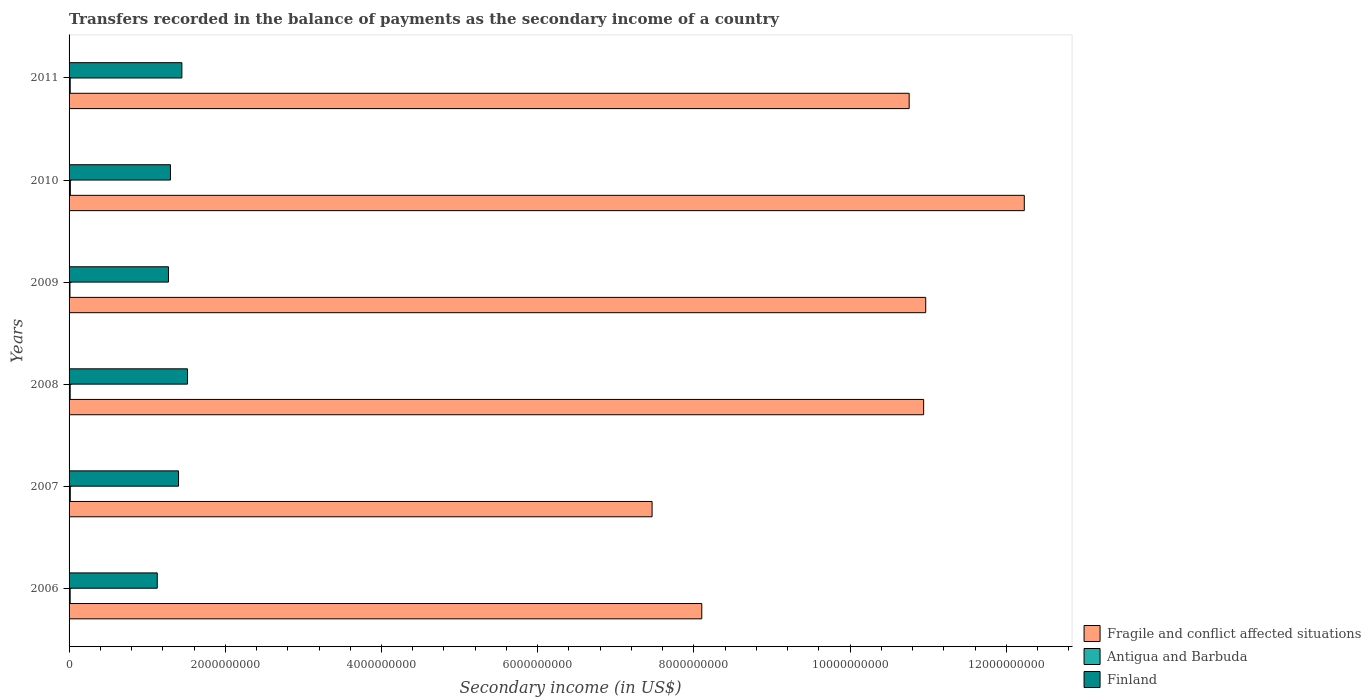How many groups of bars are there?
Provide a succinct answer. 6. Are the number of bars per tick equal to the number of legend labels?
Your answer should be very brief. Yes. How many bars are there on the 3rd tick from the bottom?
Keep it short and to the point. 3. What is the label of the 2nd group of bars from the top?
Ensure brevity in your answer.  2010. In how many cases, is the number of bars for a given year not equal to the number of legend labels?
Provide a succinct answer. 0. What is the secondary income of in Finland in 2010?
Make the answer very short. 1.30e+09. Across all years, what is the maximum secondary income of in Fragile and conflict affected situations?
Your answer should be compact. 1.22e+1. Across all years, what is the minimum secondary income of in Antigua and Barbuda?
Offer a terse response. 1.14e+07. What is the total secondary income of in Antigua and Barbuda in the graph?
Give a very brief answer. 8.55e+07. What is the difference between the secondary income of in Finland in 2006 and that in 2011?
Your answer should be very brief. -3.15e+08. What is the difference between the secondary income of in Finland in 2009 and the secondary income of in Fragile and conflict affected situations in 2007?
Provide a succinct answer. -6.19e+09. What is the average secondary income of in Antigua and Barbuda per year?
Your response must be concise. 1.42e+07. In the year 2009, what is the difference between the secondary income of in Fragile and conflict affected situations and secondary income of in Finland?
Offer a terse response. 9.70e+09. In how many years, is the secondary income of in Fragile and conflict affected situations greater than 1200000000 US$?
Provide a short and direct response. 6. What is the ratio of the secondary income of in Finland in 2006 to that in 2008?
Provide a short and direct response. 0.74. Is the secondary income of in Finland in 2007 less than that in 2011?
Offer a terse response. Yes. Is the difference between the secondary income of in Fragile and conflict affected situations in 2007 and 2009 greater than the difference between the secondary income of in Finland in 2007 and 2009?
Offer a very short reply. No. What is the difference between the highest and the second highest secondary income of in Antigua and Barbuda?
Provide a short and direct response. 4.28e+05. What is the difference between the highest and the lowest secondary income of in Antigua and Barbuda?
Offer a very short reply. 4.58e+06. In how many years, is the secondary income of in Antigua and Barbuda greater than the average secondary income of in Antigua and Barbuda taken over all years?
Ensure brevity in your answer.  3. What does the 1st bar from the bottom in 2008 represents?
Make the answer very short. Fragile and conflict affected situations. How many bars are there?
Offer a very short reply. 18. How many years are there in the graph?
Your answer should be very brief. 6. What is the difference between two consecutive major ticks on the X-axis?
Your response must be concise. 2.00e+09. Does the graph contain grids?
Your answer should be compact. No. Where does the legend appear in the graph?
Give a very brief answer. Bottom right. What is the title of the graph?
Make the answer very short. Transfers recorded in the balance of payments as the secondary income of a country. Does "Switzerland" appear as one of the legend labels in the graph?
Keep it short and to the point. No. What is the label or title of the X-axis?
Your answer should be compact. Secondary income (in US$). What is the Secondary income (in US$) in Fragile and conflict affected situations in 2006?
Provide a short and direct response. 8.10e+09. What is the Secondary income (in US$) of Antigua and Barbuda in 2006?
Make the answer very short. 1.39e+07. What is the Secondary income (in US$) of Finland in 2006?
Give a very brief answer. 1.13e+09. What is the Secondary income (in US$) in Fragile and conflict affected situations in 2007?
Your response must be concise. 7.46e+09. What is the Secondary income (in US$) in Antigua and Barbuda in 2007?
Provide a short and direct response. 1.56e+07. What is the Secondary income (in US$) in Finland in 2007?
Give a very brief answer. 1.40e+09. What is the Secondary income (in US$) in Fragile and conflict affected situations in 2008?
Ensure brevity in your answer.  1.09e+1. What is the Secondary income (in US$) of Antigua and Barbuda in 2008?
Keep it short and to the point. 1.40e+07. What is the Secondary income (in US$) in Finland in 2008?
Provide a succinct answer. 1.52e+09. What is the Secondary income (in US$) of Fragile and conflict affected situations in 2009?
Provide a succinct answer. 1.10e+1. What is the Secondary income (in US$) in Antigua and Barbuda in 2009?
Give a very brief answer. 1.14e+07. What is the Secondary income (in US$) of Finland in 2009?
Keep it short and to the point. 1.27e+09. What is the Secondary income (in US$) of Fragile and conflict affected situations in 2010?
Your answer should be compact. 1.22e+1. What is the Secondary income (in US$) of Antigua and Barbuda in 2010?
Your answer should be compact. 1.60e+07. What is the Secondary income (in US$) of Finland in 2010?
Offer a terse response. 1.30e+09. What is the Secondary income (in US$) in Fragile and conflict affected situations in 2011?
Offer a very short reply. 1.08e+1. What is the Secondary income (in US$) in Antigua and Barbuda in 2011?
Give a very brief answer. 1.45e+07. What is the Secondary income (in US$) in Finland in 2011?
Provide a short and direct response. 1.44e+09. Across all years, what is the maximum Secondary income (in US$) in Fragile and conflict affected situations?
Your response must be concise. 1.22e+1. Across all years, what is the maximum Secondary income (in US$) of Antigua and Barbuda?
Give a very brief answer. 1.60e+07. Across all years, what is the maximum Secondary income (in US$) in Finland?
Make the answer very short. 1.52e+09. Across all years, what is the minimum Secondary income (in US$) in Fragile and conflict affected situations?
Offer a terse response. 7.46e+09. Across all years, what is the minimum Secondary income (in US$) in Antigua and Barbuda?
Make the answer very short. 1.14e+07. Across all years, what is the minimum Secondary income (in US$) in Finland?
Provide a succinct answer. 1.13e+09. What is the total Secondary income (in US$) of Fragile and conflict affected situations in the graph?
Provide a short and direct response. 6.05e+1. What is the total Secondary income (in US$) of Antigua and Barbuda in the graph?
Your answer should be very brief. 8.55e+07. What is the total Secondary income (in US$) of Finland in the graph?
Offer a very short reply. 8.06e+09. What is the difference between the Secondary income (in US$) in Fragile and conflict affected situations in 2006 and that in 2007?
Ensure brevity in your answer.  6.36e+08. What is the difference between the Secondary income (in US$) in Antigua and Barbuda in 2006 and that in 2007?
Offer a terse response. -1.71e+06. What is the difference between the Secondary income (in US$) of Finland in 2006 and that in 2007?
Your answer should be compact. -2.72e+08. What is the difference between the Secondary income (in US$) of Fragile and conflict affected situations in 2006 and that in 2008?
Ensure brevity in your answer.  -2.84e+09. What is the difference between the Secondary income (in US$) in Antigua and Barbuda in 2006 and that in 2008?
Give a very brief answer. -1.47e+05. What is the difference between the Secondary income (in US$) of Finland in 2006 and that in 2008?
Make the answer very short. -3.87e+08. What is the difference between the Secondary income (in US$) in Fragile and conflict affected situations in 2006 and that in 2009?
Provide a succinct answer. -2.87e+09. What is the difference between the Secondary income (in US$) in Antigua and Barbuda in 2006 and that in 2009?
Offer a terse response. 2.44e+06. What is the difference between the Secondary income (in US$) of Finland in 2006 and that in 2009?
Provide a short and direct response. -1.43e+08. What is the difference between the Secondary income (in US$) in Fragile and conflict affected situations in 2006 and that in 2010?
Your response must be concise. -4.13e+09. What is the difference between the Secondary income (in US$) of Antigua and Barbuda in 2006 and that in 2010?
Provide a short and direct response. -2.14e+06. What is the difference between the Secondary income (in US$) in Finland in 2006 and that in 2010?
Your response must be concise. -1.69e+08. What is the difference between the Secondary income (in US$) in Fragile and conflict affected situations in 2006 and that in 2011?
Your answer should be compact. -2.66e+09. What is the difference between the Secondary income (in US$) in Antigua and Barbuda in 2006 and that in 2011?
Make the answer very short. -6.30e+05. What is the difference between the Secondary income (in US$) of Finland in 2006 and that in 2011?
Ensure brevity in your answer.  -3.15e+08. What is the difference between the Secondary income (in US$) in Fragile and conflict affected situations in 2007 and that in 2008?
Your response must be concise. -3.48e+09. What is the difference between the Secondary income (in US$) in Antigua and Barbuda in 2007 and that in 2008?
Offer a very short reply. 1.57e+06. What is the difference between the Secondary income (in US$) in Finland in 2007 and that in 2008?
Offer a terse response. -1.15e+08. What is the difference between the Secondary income (in US$) in Fragile and conflict affected situations in 2007 and that in 2009?
Keep it short and to the point. -3.50e+09. What is the difference between the Secondary income (in US$) in Antigua and Barbuda in 2007 and that in 2009?
Make the answer very short. 4.15e+06. What is the difference between the Secondary income (in US$) in Finland in 2007 and that in 2009?
Ensure brevity in your answer.  1.29e+08. What is the difference between the Secondary income (in US$) in Fragile and conflict affected situations in 2007 and that in 2010?
Ensure brevity in your answer.  -4.77e+09. What is the difference between the Secondary income (in US$) of Antigua and Barbuda in 2007 and that in 2010?
Ensure brevity in your answer.  -4.28e+05. What is the difference between the Secondary income (in US$) in Finland in 2007 and that in 2010?
Provide a short and direct response. 1.03e+08. What is the difference between the Secondary income (in US$) in Fragile and conflict affected situations in 2007 and that in 2011?
Offer a very short reply. -3.29e+09. What is the difference between the Secondary income (in US$) of Antigua and Barbuda in 2007 and that in 2011?
Give a very brief answer. 1.08e+06. What is the difference between the Secondary income (in US$) of Finland in 2007 and that in 2011?
Your answer should be compact. -4.30e+07. What is the difference between the Secondary income (in US$) in Fragile and conflict affected situations in 2008 and that in 2009?
Ensure brevity in your answer.  -2.65e+07. What is the difference between the Secondary income (in US$) of Antigua and Barbuda in 2008 and that in 2009?
Offer a very short reply. 2.59e+06. What is the difference between the Secondary income (in US$) of Finland in 2008 and that in 2009?
Ensure brevity in your answer.  2.44e+08. What is the difference between the Secondary income (in US$) of Fragile and conflict affected situations in 2008 and that in 2010?
Your response must be concise. -1.29e+09. What is the difference between the Secondary income (in US$) in Antigua and Barbuda in 2008 and that in 2010?
Provide a short and direct response. -2.00e+06. What is the difference between the Secondary income (in US$) of Finland in 2008 and that in 2010?
Make the answer very short. 2.18e+08. What is the difference between the Secondary income (in US$) in Fragile and conflict affected situations in 2008 and that in 2011?
Ensure brevity in your answer.  1.85e+08. What is the difference between the Secondary income (in US$) in Antigua and Barbuda in 2008 and that in 2011?
Your answer should be compact. -4.83e+05. What is the difference between the Secondary income (in US$) in Finland in 2008 and that in 2011?
Your answer should be compact. 7.19e+07. What is the difference between the Secondary income (in US$) in Fragile and conflict affected situations in 2009 and that in 2010?
Your response must be concise. -1.26e+09. What is the difference between the Secondary income (in US$) of Antigua and Barbuda in 2009 and that in 2010?
Your answer should be compact. -4.58e+06. What is the difference between the Secondary income (in US$) in Finland in 2009 and that in 2010?
Provide a succinct answer. -2.53e+07. What is the difference between the Secondary income (in US$) of Fragile and conflict affected situations in 2009 and that in 2011?
Offer a terse response. 2.12e+08. What is the difference between the Secondary income (in US$) of Antigua and Barbuda in 2009 and that in 2011?
Your answer should be very brief. -3.07e+06. What is the difference between the Secondary income (in US$) of Finland in 2009 and that in 2011?
Offer a terse response. -1.72e+08. What is the difference between the Secondary income (in US$) of Fragile and conflict affected situations in 2010 and that in 2011?
Your answer should be very brief. 1.47e+09. What is the difference between the Secondary income (in US$) in Antigua and Barbuda in 2010 and that in 2011?
Provide a short and direct response. 1.51e+06. What is the difference between the Secondary income (in US$) in Finland in 2010 and that in 2011?
Offer a very short reply. -1.46e+08. What is the difference between the Secondary income (in US$) in Fragile and conflict affected situations in 2006 and the Secondary income (in US$) in Antigua and Barbuda in 2007?
Your answer should be compact. 8.09e+09. What is the difference between the Secondary income (in US$) of Fragile and conflict affected situations in 2006 and the Secondary income (in US$) of Finland in 2007?
Give a very brief answer. 6.70e+09. What is the difference between the Secondary income (in US$) in Antigua and Barbuda in 2006 and the Secondary income (in US$) in Finland in 2007?
Give a very brief answer. -1.39e+09. What is the difference between the Secondary income (in US$) in Fragile and conflict affected situations in 2006 and the Secondary income (in US$) in Antigua and Barbuda in 2008?
Ensure brevity in your answer.  8.09e+09. What is the difference between the Secondary income (in US$) of Fragile and conflict affected situations in 2006 and the Secondary income (in US$) of Finland in 2008?
Provide a short and direct response. 6.58e+09. What is the difference between the Secondary income (in US$) of Antigua and Barbuda in 2006 and the Secondary income (in US$) of Finland in 2008?
Your response must be concise. -1.50e+09. What is the difference between the Secondary income (in US$) of Fragile and conflict affected situations in 2006 and the Secondary income (in US$) of Antigua and Barbuda in 2009?
Provide a succinct answer. 8.09e+09. What is the difference between the Secondary income (in US$) in Fragile and conflict affected situations in 2006 and the Secondary income (in US$) in Finland in 2009?
Make the answer very short. 6.83e+09. What is the difference between the Secondary income (in US$) in Antigua and Barbuda in 2006 and the Secondary income (in US$) in Finland in 2009?
Offer a very short reply. -1.26e+09. What is the difference between the Secondary income (in US$) in Fragile and conflict affected situations in 2006 and the Secondary income (in US$) in Antigua and Barbuda in 2010?
Provide a short and direct response. 8.09e+09. What is the difference between the Secondary income (in US$) of Fragile and conflict affected situations in 2006 and the Secondary income (in US$) of Finland in 2010?
Your answer should be compact. 6.80e+09. What is the difference between the Secondary income (in US$) in Antigua and Barbuda in 2006 and the Secondary income (in US$) in Finland in 2010?
Provide a succinct answer. -1.28e+09. What is the difference between the Secondary income (in US$) of Fragile and conflict affected situations in 2006 and the Secondary income (in US$) of Antigua and Barbuda in 2011?
Offer a terse response. 8.09e+09. What is the difference between the Secondary income (in US$) of Fragile and conflict affected situations in 2006 and the Secondary income (in US$) of Finland in 2011?
Your response must be concise. 6.66e+09. What is the difference between the Secondary income (in US$) of Antigua and Barbuda in 2006 and the Secondary income (in US$) of Finland in 2011?
Provide a succinct answer. -1.43e+09. What is the difference between the Secondary income (in US$) in Fragile and conflict affected situations in 2007 and the Secondary income (in US$) in Antigua and Barbuda in 2008?
Your response must be concise. 7.45e+09. What is the difference between the Secondary income (in US$) in Fragile and conflict affected situations in 2007 and the Secondary income (in US$) in Finland in 2008?
Ensure brevity in your answer.  5.95e+09. What is the difference between the Secondary income (in US$) of Antigua and Barbuda in 2007 and the Secondary income (in US$) of Finland in 2008?
Give a very brief answer. -1.50e+09. What is the difference between the Secondary income (in US$) of Fragile and conflict affected situations in 2007 and the Secondary income (in US$) of Antigua and Barbuda in 2009?
Your response must be concise. 7.45e+09. What is the difference between the Secondary income (in US$) of Fragile and conflict affected situations in 2007 and the Secondary income (in US$) of Finland in 2009?
Keep it short and to the point. 6.19e+09. What is the difference between the Secondary income (in US$) in Antigua and Barbuda in 2007 and the Secondary income (in US$) in Finland in 2009?
Your answer should be compact. -1.26e+09. What is the difference between the Secondary income (in US$) of Fragile and conflict affected situations in 2007 and the Secondary income (in US$) of Antigua and Barbuda in 2010?
Offer a terse response. 7.45e+09. What is the difference between the Secondary income (in US$) of Fragile and conflict affected situations in 2007 and the Secondary income (in US$) of Finland in 2010?
Offer a terse response. 6.17e+09. What is the difference between the Secondary income (in US$) in Antigua and Barbuda in 2007 and the Secondary income (in US$) in Finland in 2010?
Offer a very short reply. -1.28e+09. What is the difference between the Secondary income (in US$) in Fragile and conflict affected situations in 2007 and the Secondary income (in US$) in Antigua and Barbuda in 2011?
Provide a short and direct response. 7.45e+09. What is the difference between the Secondary income (in US$) in Fragile and conflict affected situations in 2007 and the Secondary income (in US$) in Finland in 2011?
Your answer should be very brief. 6.02e+09. What is the difference between the Secondary income (in US$) of Antigua and Barbuda in 2007 and the Secondary income (in US$) of Finland in 2011?
Give a very brief answer. -1.43e+09. What is the difference between the Secondary income (in US$) of Fragile and conflict affected situations in 2008 and the Secondary income (in US$) of Antigua and Barbuda in 2009?
Give a very brief answer. 1.09e+1. What is the difference between the Secondary income (in US$) of Fragile and conflict affected situations in 2008 and the Secondary income (in US$) of Finland in 2009?
Offer a terse response. 9.67e+09. What is the difference between the Secondary income (in US$) of Antigua and Barbuda in 2008 and the Secondary income (in US$) of Finland in 2009?
Ensure brevity in your answer.  -1.26e+09. What is the difference between the Secondary income (in US$) in Fragile and conflict affected situations in 2008 and the Secondary income (in US$) in Antigua and Barbuda in 2010?
Make the answer very short. 1.09e+1. What is the difference between the Secondary income (in US$) of Fragile and conflict affected situations in 2008 and the Secondary income (in US$) of Finland in 2010?
Your answer should be very brief. 9.64e+09. What is the difference between the Secondary income (in US$) in Antigua and Barbuda in 2008 and the Secondary income (in US$) in Finland in 2010?
Provide a short and direct response. -1.28e+09. What is the difference between the Secondary income (in US$) of Fragile and conflict affected situations in 2008 and the Secondary income (in US$) of Antigua and Barbuda in 2011?
Your answer should be compact. 1.09e+1. What is the difference between the Secondary income (in US$) in Fragile and conflict affected situations in 2008 and the Secondary income (in US$) in Finland in 2011?
Offer a terse response. 9.50e+09. What is the difference between the Secondary income (in US$) in Antigua and Barbuda in 2008 and the Secondary income (in US$) in Finland in 2011?
Your answer should be compact. -1.43e+09. What is the difference between the Secondary income (in US$) in Fragile and conflict affected situations in 2009 and the Secondary income (in US$) in Antigua and Barbuda in 2010?
Make the answer very short. 1.10e+1. What is the difference between the Secondary income (in US$) in Fragile and conflict affected situations in 2009 and the Secondary income (in US$) in Finland in 2010?
Offer a terse response. 9.67e+09. What is the difference between the Secondary income (in US$) of Antigua and Barbuda in 2009 and the Secondary income (in US$) of Finland in 2010?
Ensure brevity in your answer.  -1.29e+09. What is the difference between the Secondary income (in US$) in Fragile and conflict affected situations in 2009 and the Secondary income (in US$) in Antigua and Barbuda in 2011?
Ensure brevity in your answer.  1.10e+1. What is the difference between the Secondary income (in US$) in Fragile and conflict affected situations in 2009 and the Secondary income (in US$) in Finland in 2011?
Your answer should be very brief. 9.52e+09. What is the difference between the Secondary income (in US$) in Antigua and Barbuda in 2009 and the Secondary income (in US$) in Finland in 2011?
Make the answer very short. -1.43e+09. What is the difference between the Secondary income (in US$) of Fragile and conflict affected situations in 2010 and the Secondary income (in US$) of Antigua and Barbuda in 2011?
Ensure brevity in your answer.  1.22e+1. What is the difference between the Secondary income (in US$) in Fragile and conflict affected situations in 2010 and the Secondary income (in US$) in Finland in 2011?
Offer a terse response. 1.08e+1. What is the difference between the Secondary income (in US$) of Antigua and Barbuda in 2010 and the Secondary income (in US$) of Finland in 2011?
Provide a short and direct response. -1.43e+09. What is the average Secondary income (in US$) of Fragile and conflict affected situations per year?
Give a very brief answer. 1.01e+1. What is the average Secondary income (in US$) of Antigua and Barbuda per year?
Keep it short and to the point. 1.42e+07. What is the average Secondary income (in US$) of Finland per year?
Ensure brevity in your answer.  1.34e+09. In the year 2006, what is the difference between the Secondary income (in US$) of Fragile and conflict affected situations and Secondary income (in US$) of Antigua and Barbuda?
Your response must be concise. 8.09e+09. In the year 2006, what is the difference between the Secondary income (in US$) in Fragile and conflict affected situations and Secondary income (in US$) in Finland?
Your answer should be very brief. 6.97e+09. In the year 2006, what is the difference between the Secondary income (in US$) of Antigua and Barbuda and Secondary income (in US$) of Finland?
Offer a terse response. -1.12e+09. In the year 2007, what is the difference between the Secondary income (in US$) in Fragile and conflict affected situations and Secondary income (in US$) in Antigua and Barbuda?
Your answer should be compact. 7.45e+09. In the year 2007, what is the difference between the Secondary income (in US$) of Fragile and conflict affected situations and Secondary income (in US$) of Finland?
Keep it short and to the point. 6.06e+09. In the year 2007, what is the difference between the Secondary income (in US$) in Antigua and Barbuda and Secondary income (in US$) in Finland?
Ensure brevity in your answer.  -1.39e+09. In the year 2008, what is the difference between the Secondary income (in US$) of Fragile and conflict affected situations and Secondary income (in US$) of Antigua and Barbuda?
Ensure brevity in your answer.  1.09e+1. In the year 2008, what is the difference between the Secondary income (in US$) in Fragile and conflict affected situations and Secondary income (in US$) in Finland?
Offer a very short reply. 9.43e+09. In the year 2008, what is the difference between the Secondary income (in US$) in Antigua and Barbuda and Secondary income (in US$) in Finland?
Provide a succinct answer. -1.50e+09. In the year 2009, what is the difference between the Secondary income (in US$) in Fragile and conflict affected situations and Secondary income (in US$) in Antigua and Barbuda?
Provide a succinct answer. 1.10e+1. In the year 2009, what is the difference between the Secondary income (in US$) in Fragile and conflict affected situations and Secondary income (in US$) in Finland?
Provide a short and direct response. 9.70e+09. In the year 2009, what is the difference between the Secondary income (in US$) of Antigua and Barbuda and Secondary income (in US$) of Finland?
Offer a very short reply. -1.26e+09. In the year 2010, what is the difference between the Secondary income (in US$) of Fragile and conflict affected situations and Secondary income (in US$) of Antigua and Barbuda?
Provide a succinct answer. 1.22e+1. In the year 2010, what is the difference between the Secondary income (in US$) of Fragile and conflict affected situations and Secondary income (in US$) of Finland?
Your response must be concise. 1.09e+1. In the year 2010, what is the difference between the Secondary income (in US$) of Antigua and Barbuda and Secondary income (in US$) of Finland?
Your answer should be compact. -1.28e+09. In the year 2011, what is the difference between the Secondary income (in US$) in Fragile and conflict affected situations and Secondary income (in US$) in Antigua and Barbuda?
Offer a very short reply. 1.07e+1. In the year 2011, what is the difference between the Secondary income (in US$) in Fragile and conflict affected situations and Secondary income (in US$) in Finland?
Your answer should be very brief. 9.31e+09. In the year 2011, what is the difference between the Secondary income (in US$) in Antigua and Barbuda and Secondary income (in US$) in Finland?
Your answer should be very brief. -1.43e+09. What is the ratio of the Secondary income (in US$) of Fragile and conflict affected situations in 2006 to that in 2007?
Provide a short and direct response. 1.09. What is the ratio of the Secondary income (in US$) of Antigua and Barbuda in 2006 to that in 2007?
Offer a terse response. 0.89. What is the ratio of the Secondary income (in US$) of Finland in 2006 to that in 2007?
Provide a succinct answer. 0.81. What is the ratio of the Secondary income (in US$) in Fragile and conflict affected situations in 2006 to that in 2008?
Keep it short and to the point. 0.74. What is the ratio of the Secondary income (in US$) in Antigua and Barbuda in 2006 to that in 2008?
Give a very brief answer. 0.99. What is the ratio of the Secondary income (in US$) in Finland in 2006 to that in 2008?
Your answer should be very brief. 0.74. What is the ratio of the Secondary income (in US$) of Fragile and conflict affected situations in 2006 to that in 2009?
Ensure brevity in your answer.  0.74. What is the ratio of the Secondary income (in US$) in Antigua and Barbuda in 2006 to that in 2009?
Give a very brief answer. 1.21. What is the ratio of the Secondary income (in US$) of Finland in 2006 to that in 2009?
Ensure brevity in your answer.  0.89. What is the ratio of the Secondary income (in US$) in Fragile and conflict affected situations in 2006 to that in 2010?
Your answer should be compact. 0.66. What is the ratio of the Secondary income (in US$) in Antigua and Barbuda in 2006 to that in 2010?
Provide a short and direct response. 0.87. What is the ratio of the Secondary income (in US$) of Finland in 2006 to that in 2010?
Make the answer very short. 0.87. What is the ratio of the Secondary income (in US$) in Fragile and conflict affected situations in 2006 to that in 2011?
Your answer should be very brief. 0.75. What is the ratio of the Secondary income (in US$) in Antigua and Barbuda in 2006 to that in 2011?
Give a very brief answer. 0.96. What is the ratio of the Secondary income (in US$) in Finland in 2006 to that in 2011?
Your answer should be very brief. 0.78. What is the ratio of the Secondary income (in US$) of Fragile and conflict affected situations in 2007 to that in 2008?
Your answer should be very brief. 0.68. What is the ratio of the Secondary income (in US$) of Antigua and Barbuda in 2007 to that in 2008?
Give a very brief answer. 1.11. What is the ratio of the Secondary income (in US$) of Finland in 2007 to that in 2008?
Your answer should be compact. 0.92. What is the ratio of the Secondary income (in US$) in Fragile and conflict affected situations in 2007 to that in 2009?
Offer a very short reply. 0.68. What is the ratio of the Secondary income (in US$) in Antigua and Barbuda in 2007 to that in 2009?
Keep it short and to the point. 1.36. What is the ratio of the Secondary income (in US$) in Finland in 2007 to that in 2009?
Keep it short and to the point. 1.1. What is the ratio of the Secondary income (in US$) in Fragile and conflict affected situations in 2007 to that in 2010?
Your answer should be very brief. 0.61. What is the ratio of the Secondary income (in US$) of Antigua and Barbuda in 2007 to that in 2010?
Make the answer very short. 0.97. What is the ratio of the Secondary income (in US$) in Finland in 2007 to that in 2010?
Offer a terse response. 1.08. What is the ratio of the Secondary income (in US$) in Fragile and conflict affected situations in 2007 to that in 2011?
Ensure brevity in your answer.  0.69. What is the ratio of the Secondary income (in US$) in Antigua and Barbuda in 2007 to that in 2011?
Keep it short and to the point. 1.07. What is the ratio of the Secondary income (in US$) in Finland in 2007 to that in 2011?
Make the answer very short. 0.97. What is the ratio of the Secondary income (in US$) of Fragile and conflict affected situations in 2008 to that in 2009?
Make the answer very short. 1. What is the ratio of the Secondary income (in US$) in Antigua and Barbuda in 2008 to that in 2009?
Keep it short and to the point. 1.23. What is the ratio of the Secondary income (in US$) in Finland in 2008 to that in 2009?
Provide a succinct answer. 1.19. What is the ratio of the Secondary income (in US$) of Fragile and conflict affected situations in 2008 to that in 2010?
Give a very brief answer. 0.89. What is the ratio of the Secondary income (in US$) of Antigua and Barbuda in 2008 to that in 2010?
Your answer should be compact. 0.88. What is the ratio of the Secondary income (in US$) of Finland in 2008 to that in 2010?
Your answer should be very brief. 1.17. What is the ratio of the Secondary income (in US$) of Fragile and conflict affected situations in 2008 to that in 2011?
Provide a short and direct response. 1.02. What is the ratio of the Secondary income (in US$) of Antigua and Barbuda in 2008 to that in 2011?
Give a very brief answer. 0.97. What is the ratio of the Secondary income (in US$) in Finland in 2008 to that in 2011?
Your response must be concise. 1.05. What is the ratio of the Secondary income (in US$) of Fragile and conflict affected situations in 2009 to that in 2010?
Your answer should be compact. 0.9. What is the ratio of the Secondary income (in US$) of Antigua and Barbuda in 2009 to that in 2010?
Offer a very short reply. 0.71. What is the ratio of the Secondary income (in US$) of Finland in 2009 to that in 2010?
Offer a terse response. 0.98. What is the ratio of the Secondary income (in US$) of Fragile and conflict affected situations in 2009 to that in 2011?
Provide a succinct answer. 1.02. What is the ratio of the Secondary income (in US$) of Antigua and Barbuda in 2009 to that in 2011?
Provide a short and direct response. 0.79. What is the ratio of the Secondary income (in US$) of Finland in 2009 to that in 2011?
Keep it short and to the point. 0.88. What is the ratio of the Secondary income (in US$) of Fragile and conflict affected situations in 2010 to that in 2011?
Provide a short and direct response. 1.14. What is the ratio of the Secondary income (in US$) of Antigua and Barbuda in 2010 to that in 2011?
Offer a terse response. 1.1. What is the ratio of the Secondary income (in US$) in Finland in 2010 to that in 2011?
Provide a succinct answer. 0.9. What is the difference between the highest and the second highest Secondary income (in US$) in Fragile and conflict affected situations?
Your response must be concise. 1.26e+09. What is the difference between the highest and the second highest Secondary income (in US$) in Antigua and Barbuda?
Offer a terse response. 4.28e+05. What is the difference between the highest and the second highest Secondary income (in US$) of Finland?
Your answer should be compact. 7.19e+07. What is the difference between the highest and the lowest Secondary income (in US$) of Fragile and conflict affected situations?
Make the answer very short. 4.77e+09. What is the difference between the highest and the lowest Secondary income (in US$) of Antigua and Barbuda?
Offer a terse response. 4.58e+06. What is the difference between the highest and the lowest Secondary income (in US$) in Finland?
Give a very brief answer. 3.87e+08. 